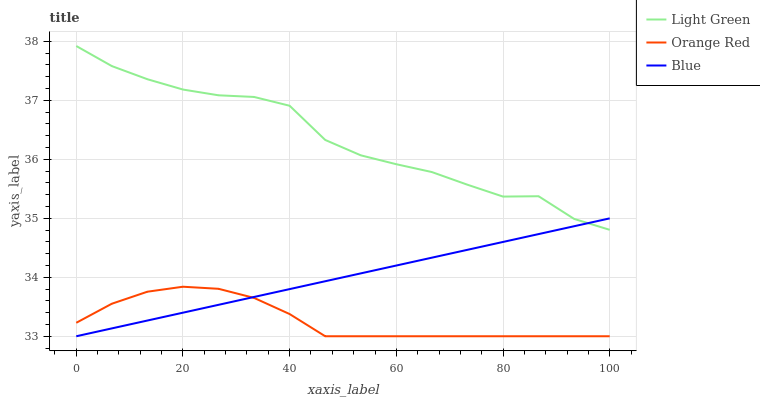Does Orange Red have the minimum area under the curve?
Answer yes or no. Yes. Does Light Green have the maximum area under the curve?
Answer yes or no. Yes. Does Light Green have the minimum area under the curve?
Answer yes or no. No. Does Orange Red have the maximum area under the curve?
Answer yes or no. No. Is Blue the smoothest?
Answer yes or no. Yes. Is Light Green the roughest?
Answer yes or no. Yes. Is Orange Red the smoothest?
Answer yes or no. No. Is Orange Red the roughest?
Answer yes or no. No. Does Blue have the lowest value?
Answer yes or no. Yes. Does Light Green have the lowest value?
Answer yes or no. No. Does Light Green have the highest value?
Answer yes or no. Yes. Does Orange Red have the highest value?
Answer yes or no. No. Is Orange Red less than Light Green?
Answer yes or no. Yes. Is Light Green greater than Orange Red?
Answer yes or no. Yes. Does Light Green intersect Blue?
Answer yes or no. Yes. Is Light Green less than Blue?
Answer yes or no. No. Is Light Green greater than Blue?
Answer yes or no. No. Does Orange Red intersect Light Green?
Answer yes or no. No. 